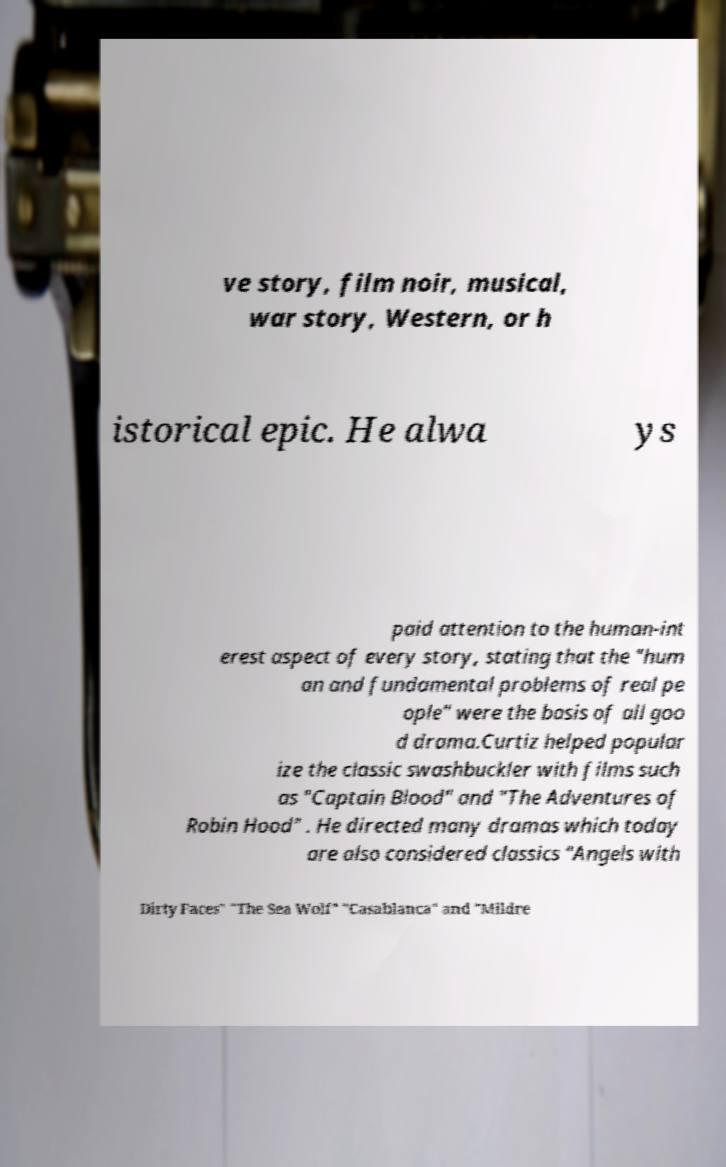For documentation purposes, I need the text within this image transcribed. Could you provide that? ve story, film noir, musical, war story, Western, or h istorical epic. He alwa ys paid attention to the human-int erest aspect of every story, stating that the "hum an and fundamental problems of real pe ople" were the basis of all goo d drama.Curtiz helped popular ize the classic swashbuckler with films such as "Captain Blood" and "The Adventures of Robin Hood" . He directed many dramas which today are also considered classics "Angels with Dirty Faces" "The Sea Wolf" "Casablanca" and "Mildre 